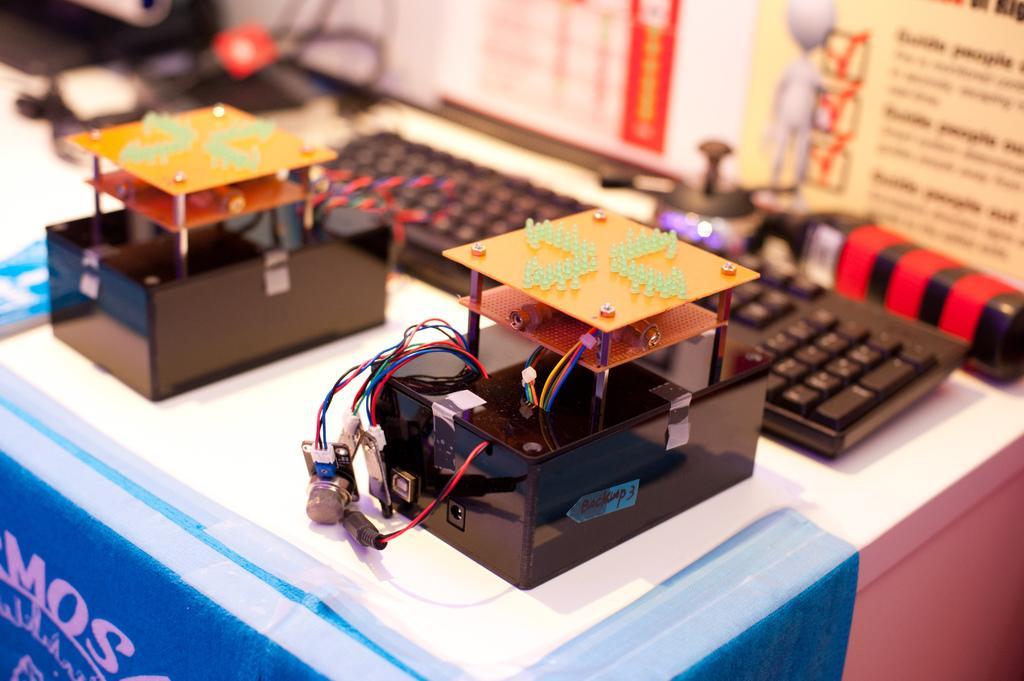Could you give a brief overview of what you see in this image? In this picture I can observe two devices placed on the blue color box. I can observe a keyboard which is in black color. On the right side there is a poster. I can observe some text on the poster. The background is blurred. 